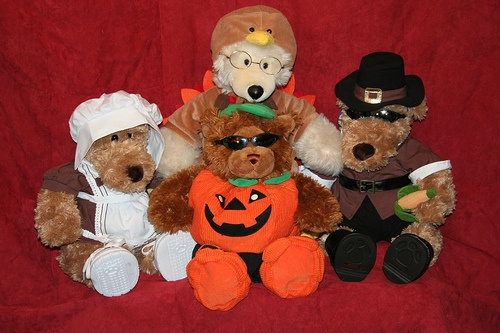Describe the objects in this image and their specific colors. I can see couch in maroon, brown, black, and red tones, teddy bear in maroon, red, brown, and black tones, teddy bear in maroon, black, and gray tones, teddy bear in maroon, lightgray, gray, and darkgray tones, and teddy bear in maroon, salmon, brown, and tan tones in this image. 